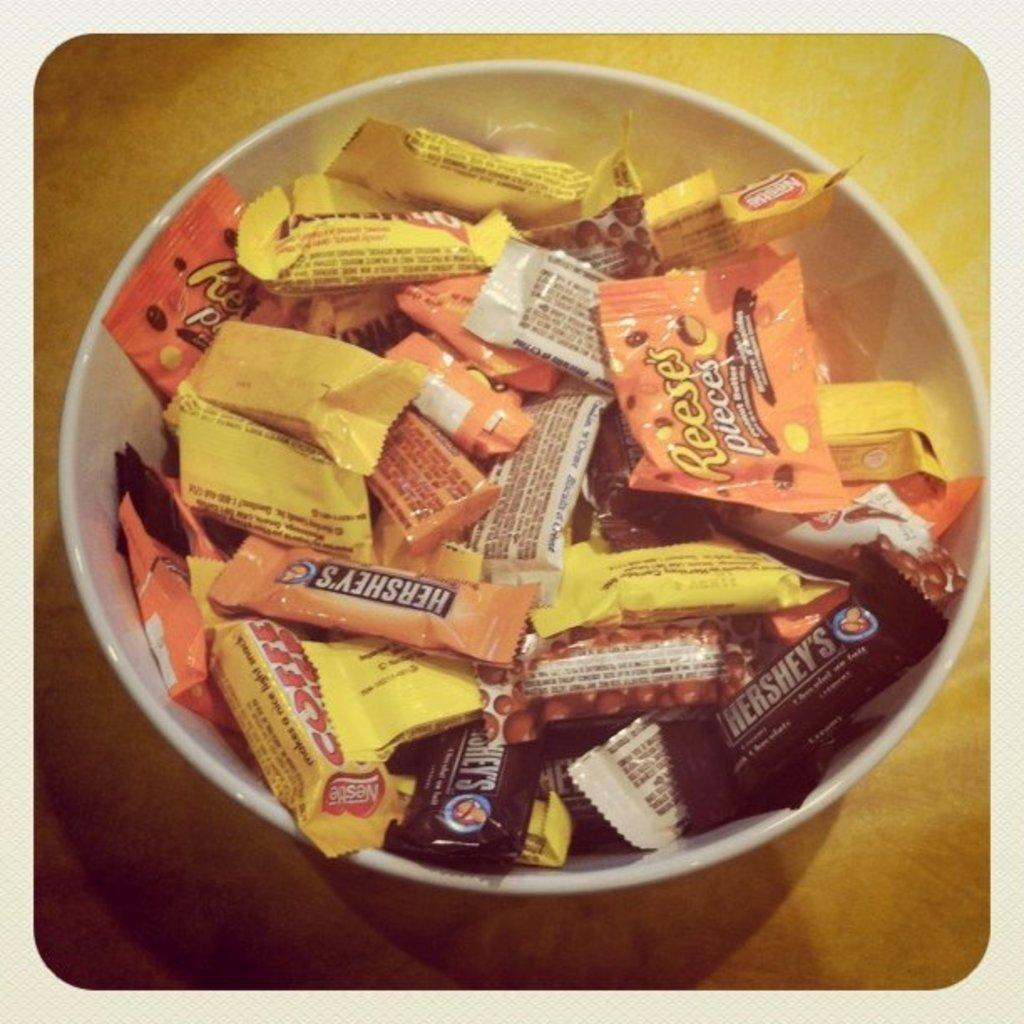What objects are present in the image? There are wrappers in the image. How are the wrappers arranged or contained? The wrappers are placed in a white bowl. Where is the white bowl located? The white bowl is placed on a platform. What is the rate of snowfall during winter in the image? There is no mention of snowfall or winter in the image, so it is not possible to determine the rate of snowfall. 